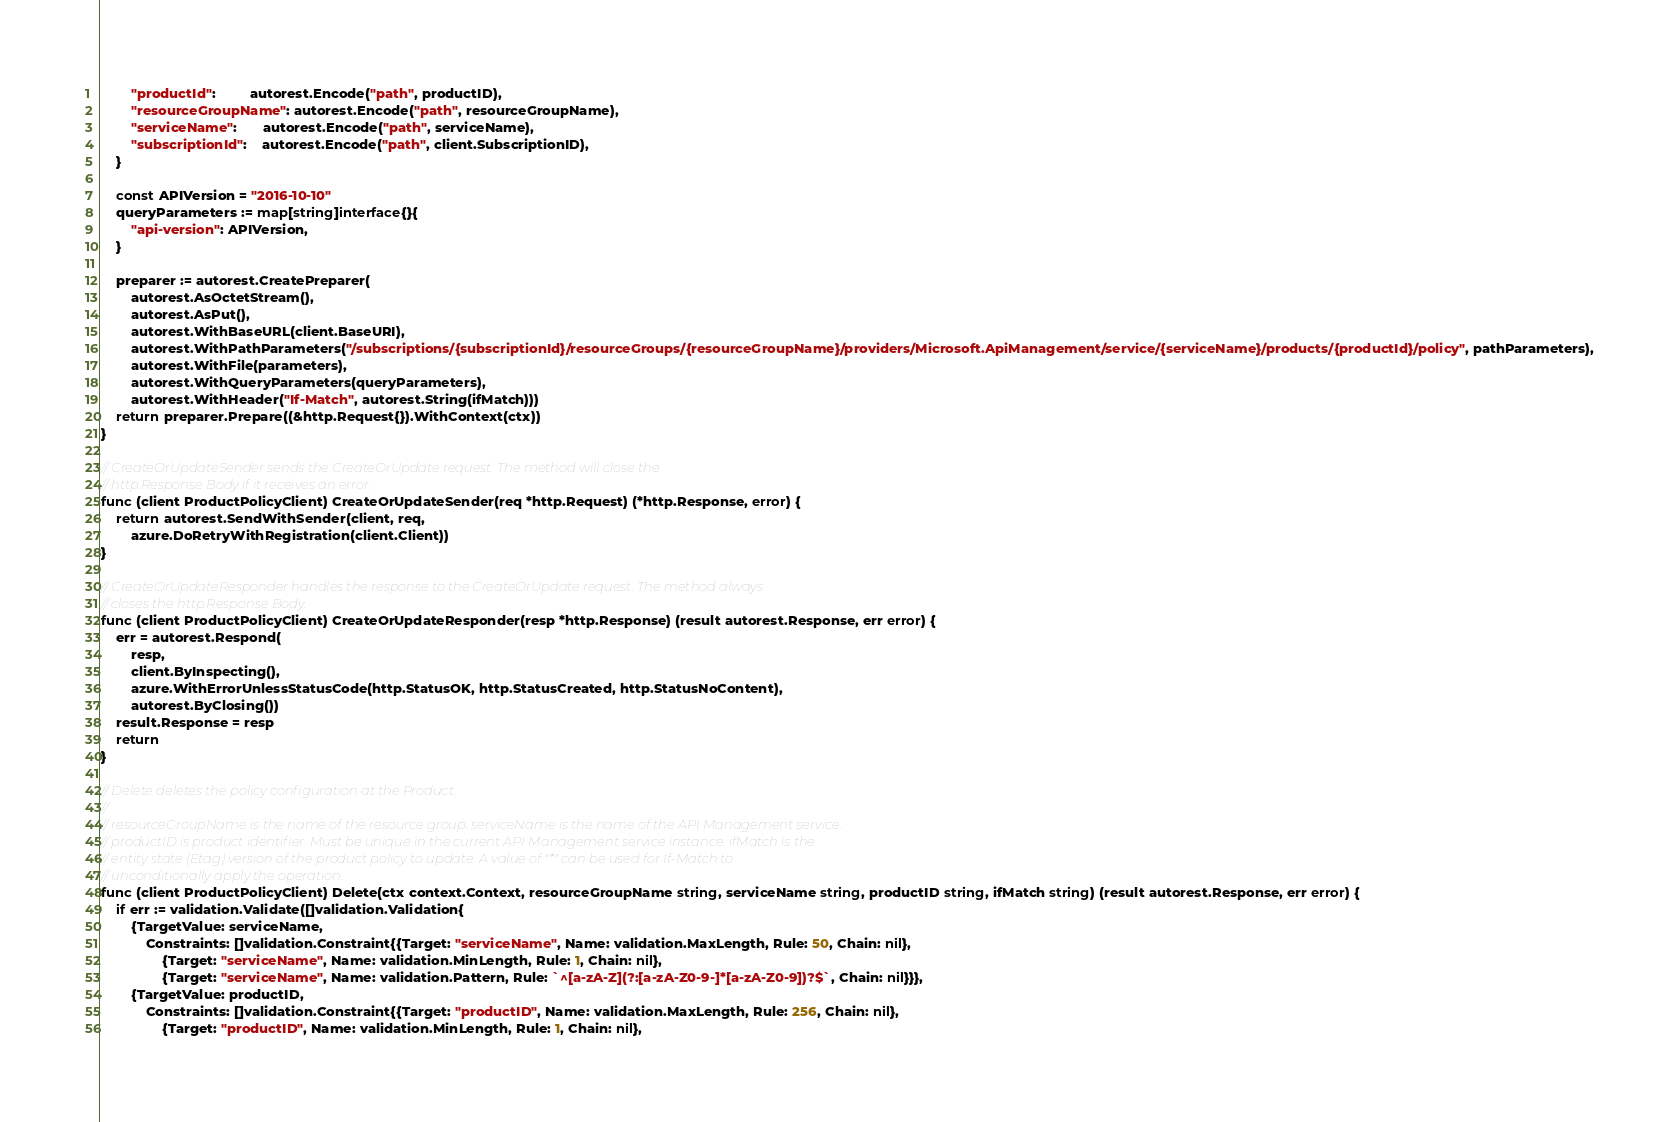Convert code to text. <code><loc_0><loc_0><loc_500><loc_500><_Go_>		"productId":         autorest.Encode("path", productID),
		"resourceGroupName": autorest.Encode("path", resourceGroupName),
		"serviceName":       autorest.Encode("path", serviceName),
		"subscriptionId":    autorest.Encode("path", client.SubscriptionID),
	}

	const APIVersion = "2016-10-10"
	queryParameters := map[string]interface{}{
		"api-version": APIVersion,
	}

	preparer := autorest.CreatePreparer(
		autorest.AsOctetStream(),
		autorest.AsPut(),
		autorest.WithBaseURL(client.BaseURI),
		autorest.WithPathParameters("/subscriptions/{subscriptionId}/resourceGroups/{resourceGroupName}/providers/Microsoft.ApiManagement/service/{serviceName}/products/{productId}/policy", pathParameters),
		autorest.WithFile(parameters),
		autorest.WithQueryParameters(queryParameters),
		autorest.WithHeader("If-Match", autorest.String(ifMatch)))
	return preparer.Prepare((&http.Request{}).WithContext(ctx))
}

// CreateOrUpdateSender sends the CreateOrUpdate request. The method will close the
// http.Response Body if it receives an error.
func (client ProductPolicyClient) CreateOrUpdateSender(req *http.Request) (*http.Response, error) {
	return autorest.SendWithSender(client, req,
		azure.DoRetryWithRegistration(client.Client))
}

// CreateOrUpdateResponder handles the response to the CreateOrUpdate request. The method always
// closes the http.Response Body.
func (client ProductPolicyClient) CreateOrUpdateResponder(resp *http.Response) (result autorest.Response, err error) {
	err = autorest.Respond(
		resp,
		client.ByInspecting(),
		azure.WithErrorUnlessStatusCode(http.StatusOK, http.StatusCreated, http.StatusNoContent),
		autorest.ByClosing())
	result.Response = resp
	return
}

// Delete deletes the policy configuration at the Product.
//
// resourceGroupName is the name of the resource group. serviceName is the name of the API Management service.
// productID is product identifier. Must be unique in the current API Management service instance. ifMatch is the
// entity state (Etag) version of the product policy to update. A value of "*" can be used for If-Match to
// unconditionally apply the operation.
func (client ProductPolicyClient) Delete(ctx context.Context, resourceGroupName string, serviceName string, productID string, ifMatch string) (result autorest.Response, err error) {
	if err := validation.Validate([]validation.Validation{
		{TargetValue: serviceName,
			Constraints: []validation.Constraint{{Target: "serviceName", Name: validation.MaxLength, Rule: 50, Chain: nil},
				{Target: "serviceName", Name: validation.MinLength, Rule: 1, Chain: nil},
				{Target: "serviceName", Name: validation.Pattern, Rule: `^[a-zA-Z](?:[a-zA-Z0-9-]*[a-zA-Z0-9])?$`, Chain: nil}}},
		{TargetValue: productID,
			Constraints: []validation.Constraint{{Target: "productID", Name: validation.MaxLength, Rule: 256, Chain: nil},
				{Target: "productID", Name: validation.MinLength, Rule: 1, Chain: nil},</code> 